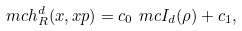Convert formula to latex. <formula><loc_0><loc_0><loc_500><loc_500>\ m c h _ { R } ^ { d } ( x , x p ) = c _ { 0 } \ m c I _ { d } ( \rho ) + c _ { 1 } ,</formula> 